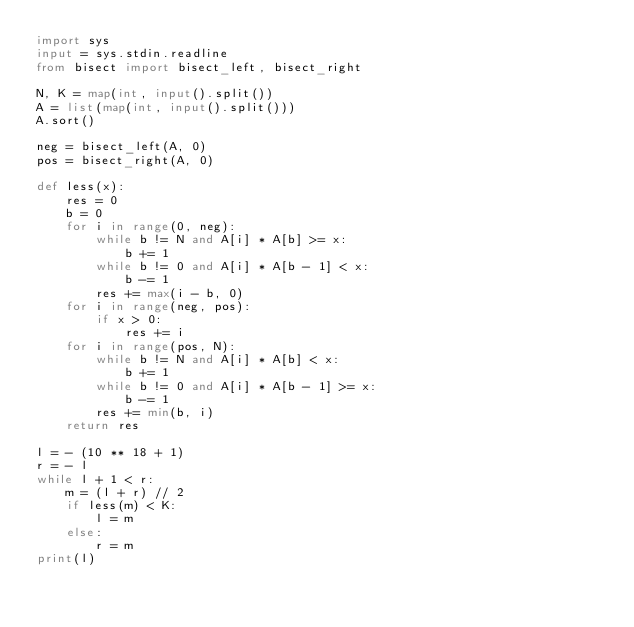<code> <loc_0><loc_0><loc_500><loc_500><_Python_>import sys
input = sys.stdin.readline
from bisect import bisect_left, bisect_right

N, K = map(int, input().split())
A = list(map(int, input().split()))
A.sort()

neg = bisect_left(A, 0)
pos = bisect_right(A, 0)

def less(x):
    res = 0
    b = 0
    for i in range(0, neg):
        while b != N and A[i] * A[b] >= x:
            b += 1
        while b != 0 and A[i] * A[b - 1] < x:
            b -= 1
        res += max(i - b, 0)
    for i in range(neg, pos):
        if x > 0:
            res += i
    for i in range(pos, N):
        while b != N and A[i] * A[b] < x:
            b += 1
        while b != 0 and A[i] * A[b - 1] >= x:
            b -= 1
        res += min(b, i)
    return res

l = - (10 ** 18 + 1)
r = - l
while l + 1 < r:
    m = (l + r) // 2
    if less(m) < K:
        l = m
    else:
        r = m
print(l)
</code> 